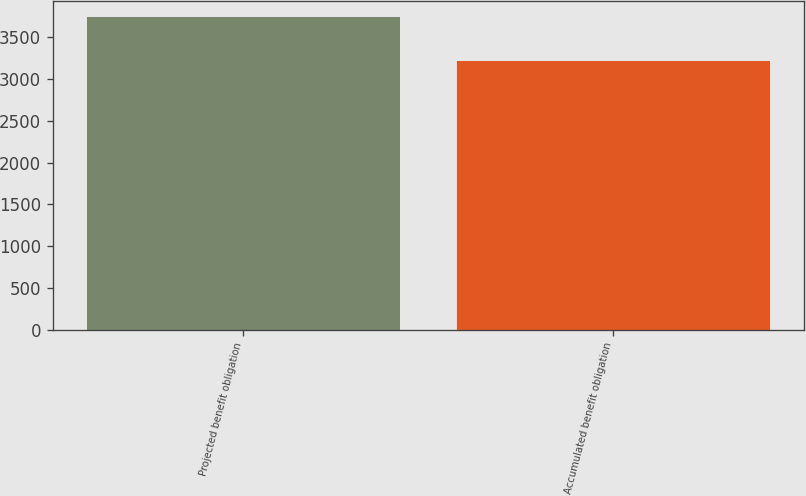Convert chart to OTSL. <chart><loc_0><loc_0><loc_500><loc_500><bar_chart><fcel>Projected benefit obligation<fcel>Accumulated benefit obligation<nl><fcel>3745<fcel>3219<nl></chart> 